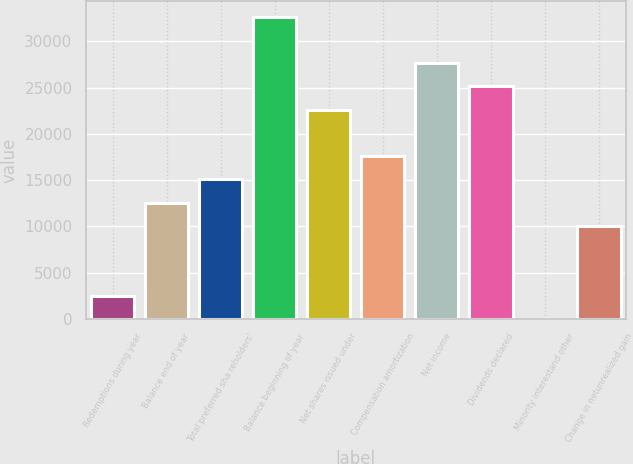Convert chart to OTSL. <chart><loc_0><loc_0><loc_500><loc_500><bar_chart><fcel>Redemptions during year<fcel>Balance end of year<fcel>Total preferred sha reholders'<fcel>Balance beginning of year<fcel>Net shares issued under<fcel>Compensation amortization<fcel>Net income<fcel>Dividends declared<fcel>Minority interestand other<fcel>Change in netunrealized gain<nl><fcel>2517.1<fcel>12569.5<fcel>15082.6<fcel>32674.3<fcel>22621.9<fcel>17595.7<fcel>27648.1<fcel>25135<fcel>4<fcel>10056.4<nl></chart> 